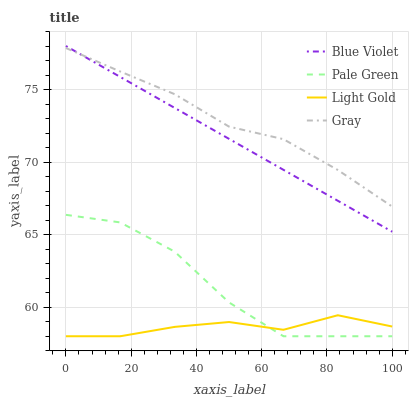Does Light Gold have the minimum area under the curve?
Answer yes or no. Yes. Does Gray have the maximum area under the curve?
Answer yes or no. Yes. Does Pale Green have the minimum area under the curve?
Answer yes or no. No. Does Pale Green have the maximum area under the curve?
Answer yes or no. No. Is Blue Violet the smoothest?
Answer yes or no. Yes. Is Pale Green the roughest?
Answer yes or no. Yes. Is Light Gold the smoothest?
Answer yes or no. No. Is Light Gold the roughest?
Answer yes or no. No. Does Pale Green have the lowest value?
Answer yes or no. Yes. Does Blue Violet have the lowest value?
Answer yes or no. No. Does Blue Violet have the highest value?
Answer yes or no. Yes. Does Pale Green have the highest value?
Answer yes or no. No. Is Light Gold less than Gray?
Answer yes or no. Yes. Is Gray greater than Light Gold?
Answer yes or no. Yes. Does Blue Violet intersect Gray?
Answer yes or no. Yes. Is Blue Violet less than Gray?
Answer yes or no. No. Is Blue Violet greater than Gray?
Answer yes or no. No. Does Light Gold intersect Gray?
Answer yes or no. No. 